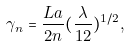<formula> <loc_0><loc_0><loc_500><loc_500>\gamma _ { n } = \frac { L a } { 2 n } ( \frac { \lambda } { 1 2 } ) ^ { 1 / 2 } ,</formula> 